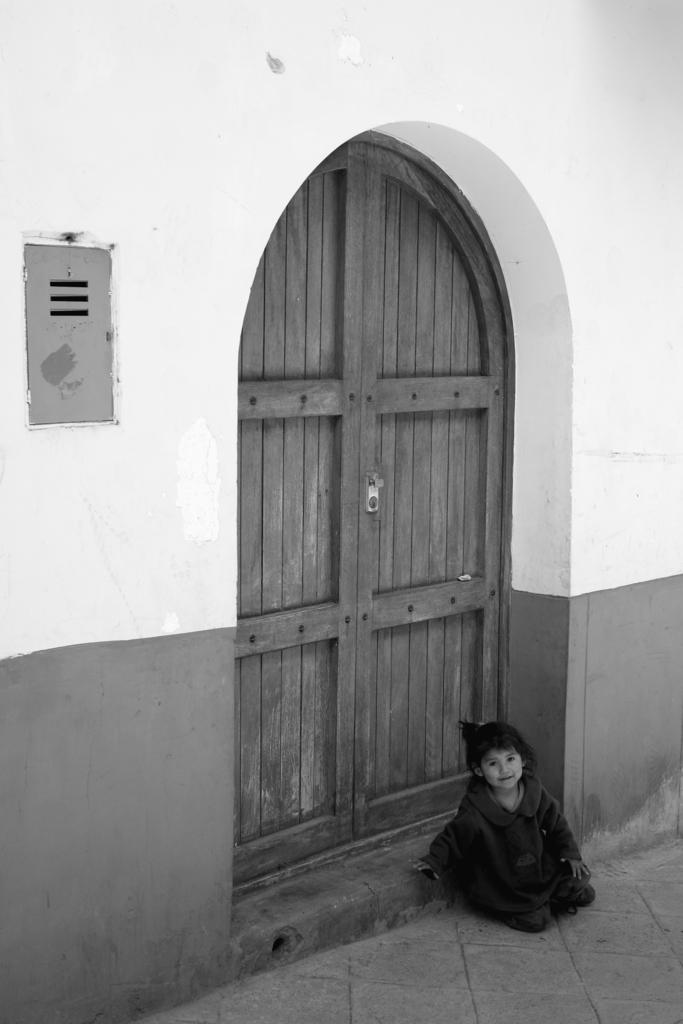What is located at the bottom of the image? There is a kid at the bottom of the image. What can be seen behind the kid? There are doors behind the kid. What type of object is on the wall on the left side of the image? There is a metal object on the wall on the left side of the image. How is the image presented in terms of color? The image is in black and white. What type of glass is being used as a vessel for a loaf in the image? There is no glass or loaf present in the image. 